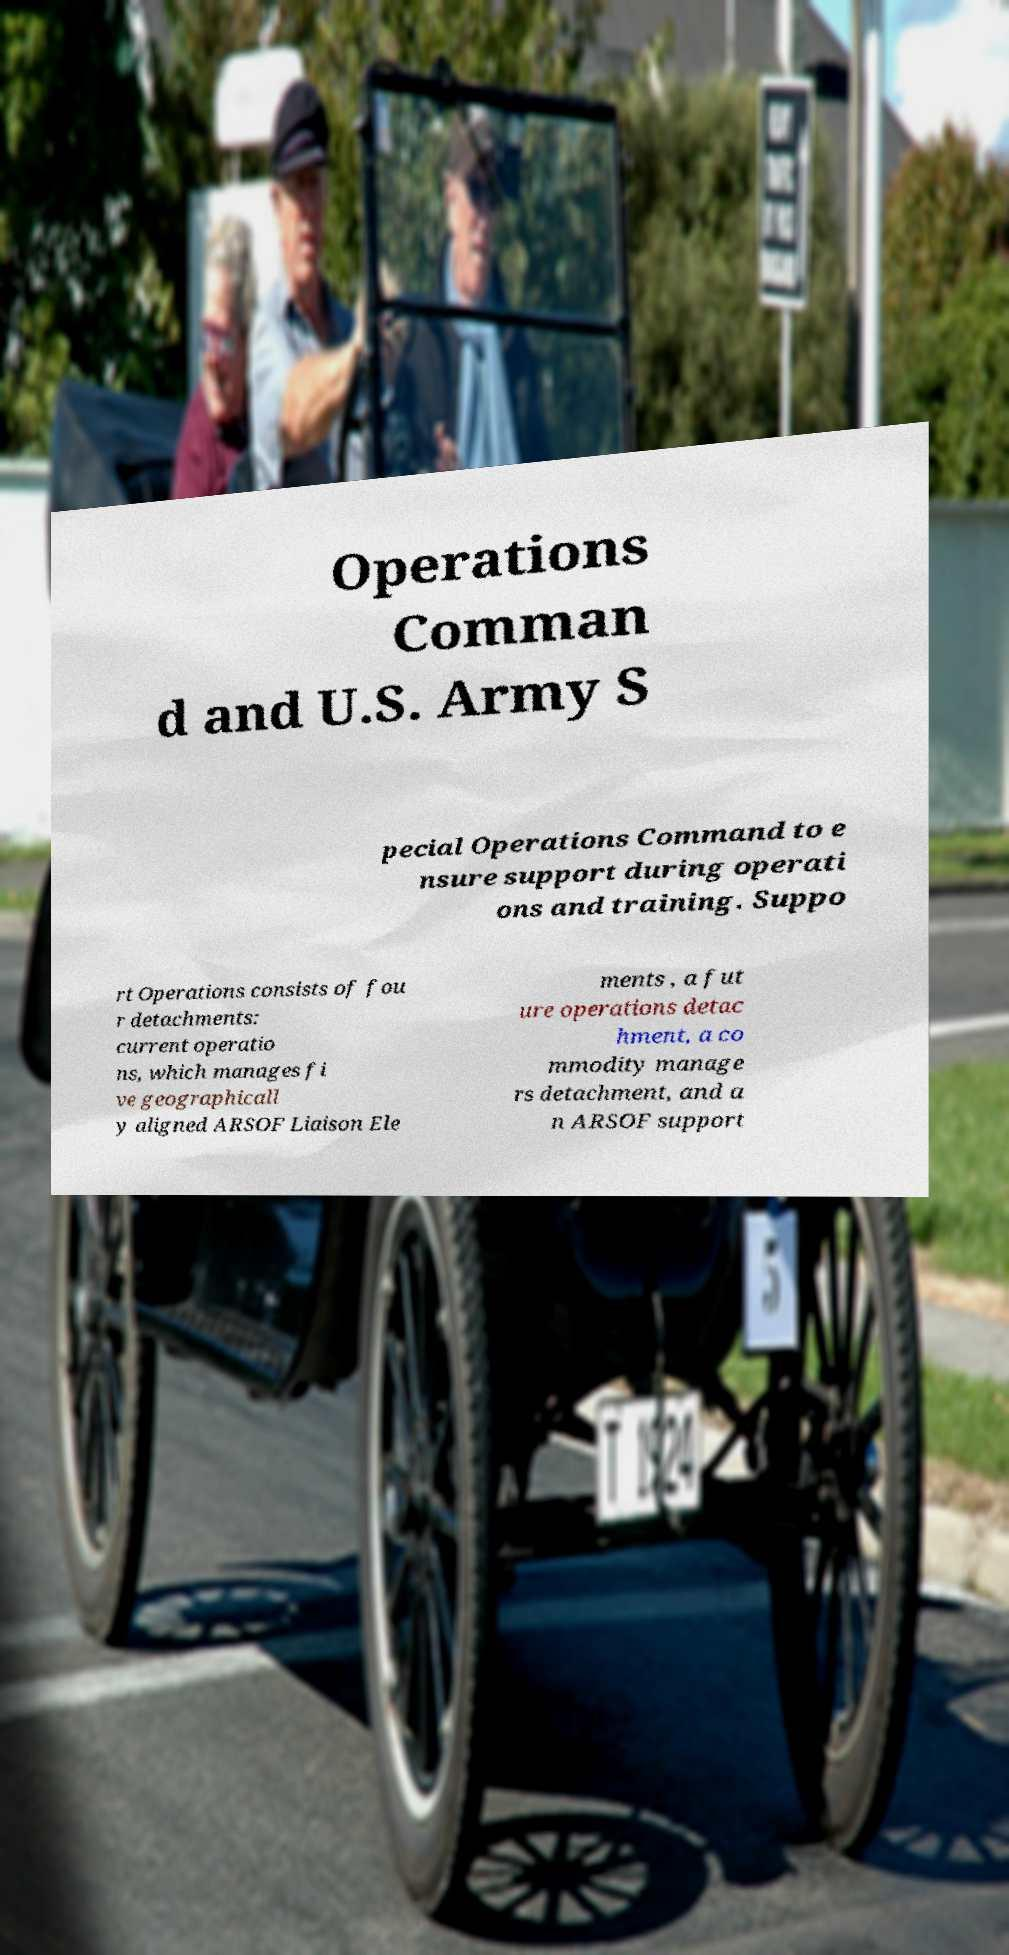What messages or text are displayed in this image? I need them in a readable, typed format. Operations Comman d and U.S. Army S pecial Operations Command to e nsure support during operati ons and training. Suppo rt Operations consists of fou r detachments: current operatio ns, which manages fi ve geographicall y aligned ARSOF Liaison Ele ments , a fut ure operations detac hment, a co mmodity manage rs detachment, and a n ARSOF support 